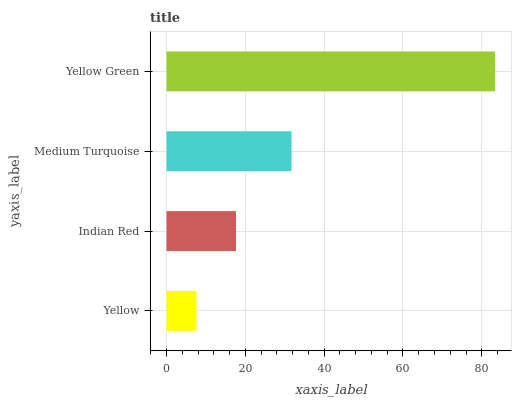Is Yellow the minimum?
Answer yes or no. Yes. Is Yellow Green the maximum?
Answer yes or no. Yes. Is Indian Red the minimum?
Answer yes or no. No. Is Indian Red the maximum?
Answer yes or no. No. Is Indian Red greater than Yellow?
Answer yes or no. Yes. Is Yellow less than Indian Red?
Answer yes or no. Yes. Is Yellow greater than Indian Red?
Answer yes or no. No. Is Indian Red less than Yellow?
Answer yes or no. No. Is Medium Turquoise the high median?
Answer yes or no. Yes. Is Indian Red the low median?
Answer yes or no. Yes. Is Yellow Green the high median?
Answer yes or no. No. Is Yellow the low median?
Answer yes or no. No. 